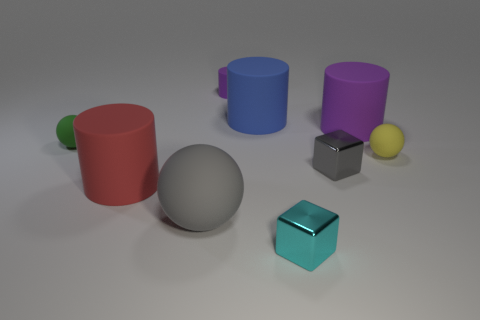What size is the block that is the same color as the large ball?
Offer a very short reply. Small. What number of things are large rubber things that are behind the tiny green matte sphere or large matte things left of the gray rubber thing?
Your answer should be very brief. 3. What is the shape of the tiny thing that is the same color as the big matte ball?
Provide a short and direct response. Cube. The small matte object on the right side of the tiny gray object has what shape?
Make the answer very short. Sphere. There is a gray object that is to the left of the gray shiny block; is its shape the same as the tiny green matte object?
Your response must be concise. Yes. What number of objects are small balls that are left of the red object or blue rubber cylinders?
Ensure brevity in your answer.  2. What color is the other tiny thing that is the same shape as the blue matte object?
Your answer should be compact. Purple. Are there any other things that have the same color as the big rubber ball?
Ensure brevity in your answer.  Yes. What size is the purple matte cylinder that is left of the blue matte thing?
Provide a succinct answer. Small. There is a small matte cylinder; is it the same color as the small shiny block that is behind the gray sphere?
Provide a short and direct response. No. 